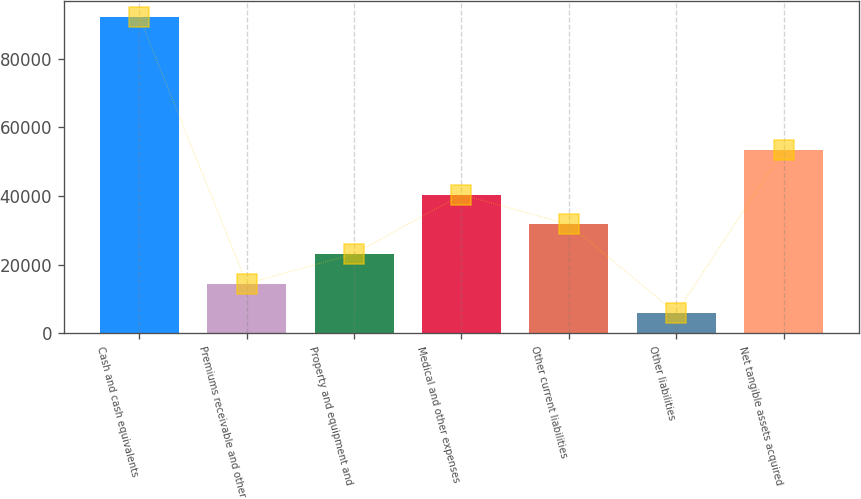Convert chart to OTSL. <chart><loc_0><loc_0><loc_500><loc_500><bar_chart><fcel>Cash and cash equivalents<fcel>Premiums receivable and other<fcel>Property and equipment and<fcel>Medical and other expenses<fcel>Other current liabilities<fcel>Other liabilities<fcel>Net tangible assets acquired<nl><fcel>92116<fcel>14535.1<fcel>23155.2<fcel>40395.4<fcel>31775.3<fcel>5915<fcel>53292<nl></chart> 